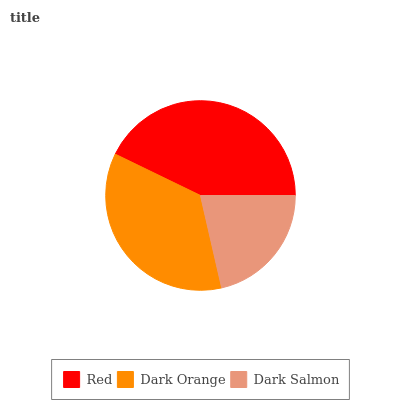Is Dark Salmon the minimum?
Answer yes or no. Yes. Is Red the maximum?
Answer yes or no. Yes. Is Dark Orange the minimum?
Answer yes or no. No. Is Dark Orange the maximum?
Answer yes or no. No. Is Red greater than Dark Orange?
Answer yes or no. Yes. Is Dark Orange less than Red?
Answer yes or no. Yes. Is Dark Orange greater than Red?
Answer yes or no. No. Is Red less than Dark Orange?
Answer yes or no. No. Is Dark Orange the high median?
Answer yes or no. Yes. Is Dark Orange the low median?
Answer yes or no. Yes. Is Dark Salmon the high median?
Answer yes or no. No. Is Dark Salmon the low median?
Answer yes or no. No. 